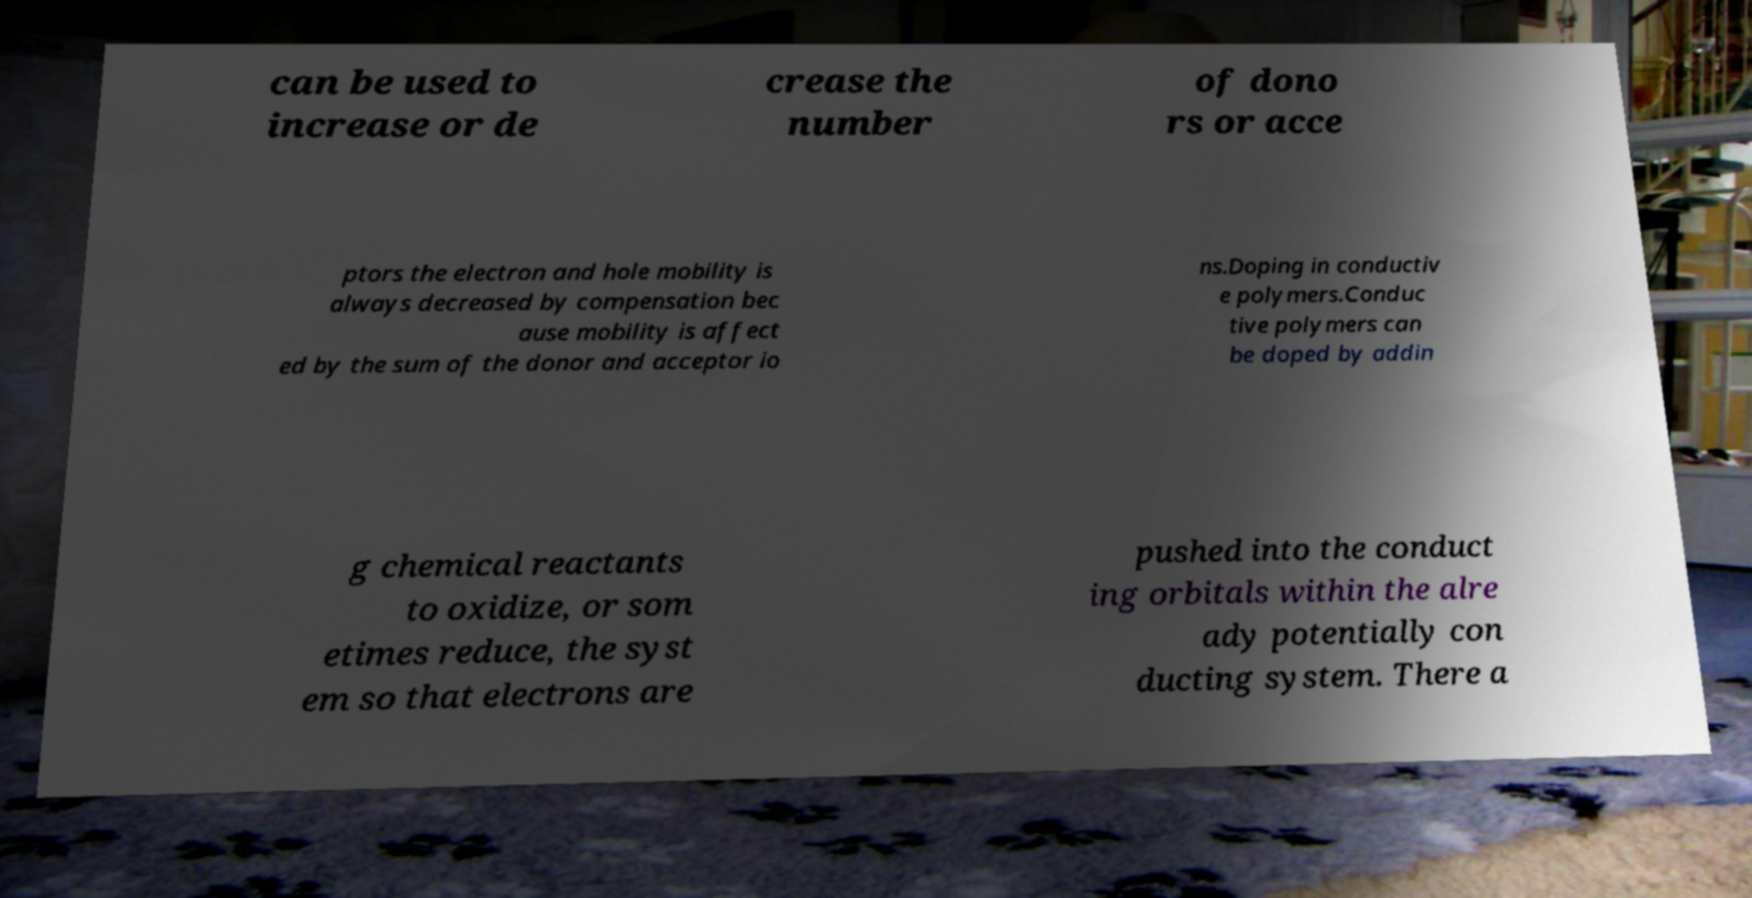Could you extract and type out the text from this image? can be used to increase or de crease the number of dono rs or acce ptors the electron and hole mobility is always decreased by compensation bec ause mobility is affect ed by the sum of the donor and acceptor io ns.Doping in conductiv e polymers.Conduc tive polymers can be doped by addin g chemical reactants to oxidize, or som etimes reduce, the syst em so that electrons are pushed into the conduct ing orbitals within the alre ady potentially con ducting system. There a 